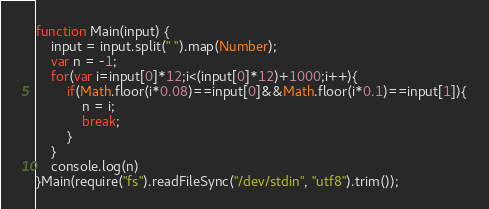<code> <loc_0><loc_0><loc_500><loc_500><_JavaScript_>function Main(input) {
	input = input.split(" ").map(Number);
	var n = -1;
	for(var i=input[0]*12;i<(input[0]*12)+1000;i++){
		if(Math.floor(i*0.08)==input[0]&&Math.floor(i*0.1)==input[1]){
			n = i;
			break;
		}
	}
	console.log(n)
}Main(require("fs").readFileSync("/dev/stdin", "utf8").trim());</code> 